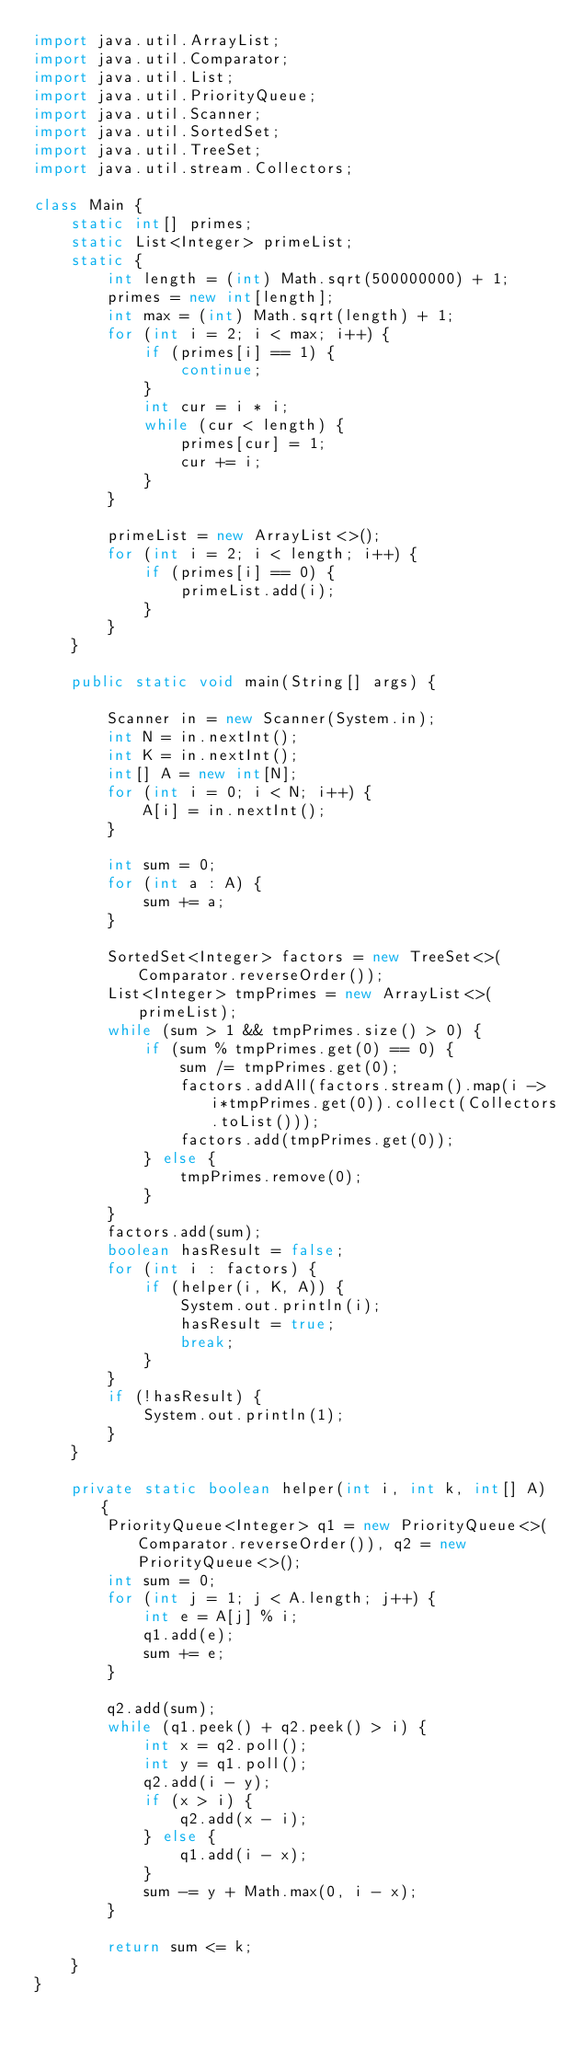<code> <loc_0><loc_0><loc_500><loc_500><_Java_>import java.util.ArrayList;
import java.util.Comparator;
import java.util.List;
import java.util.PriorityQueue;
import java.util.Scanner;
import java.util.SortedSet;
import java.util.TreeSet;
import java.util.stream.Collectors;

class Main {
    static int[] primes;
    static List<Integer> primeList;
    static {
        int length = (int) Math.sqrt(500000000) + 1;
        primes = new int[length];
        int max = (int) Math.sqrt(length) + 1;
        for (int i = 2; i < max; i++) {
            if (primes[i] == 1) {
                continue;
            }
            int cur = i * i;
            while (cur < length) {
                primes[cur] = 1;
                cur += i;
            }
        }

        primeList = new ArrayList<>();
        for (int i = 2; i < length; i++) {
            if (primes[i] == 0) {
                primeList.add(i);
            }
        }
    }

    public static void main(String[] args) {

        Scanner in = new Scanner(System.in);
        int N = in.nextInt();
        int K = in.nextInt();
        int[] A = new int[N];
        for (int i = 0; i < N; i++) {
            A[i] = in.nextInt();
        }

        int sum = 0;
        for (int a : A) {
            sum += a;
        }

        SortedSet<Integer> factors = new TreeSet<>(Comparator.reverseOrder());
        List<Integer> tmpPrimes = new ArrayList<>(primeList);
        while (sum > 1 && tmpPrimes.size() > 0) {
            if (sum % tmpPrimes.get(0) == 0) {
                sum /= tmpPrimes.get(0);
                factors.addAll(factors.stream().map(i -> i*tmpPrimes.get(0)).collect(Collectors.toList()));
                factors.add(tmpPrimes.get(0));
            } else {
                tmpPrimes.remove(0);
            }
        }
        factors.add(sum);
        boolean hasResult = false;
        for (int i : factors) {
            if (helper(i, K, A)) {
                System.out.println(i);
                hasResult = true;
                break;
            }
        }
        if (!hasResult) {
            System.out.println(1);
        }
    }

    private static boolean helper(int i, int k, int[] A) {
        PriorityQueue<Integer> q1 = new PriorityQueue<>(Comparator.reverseOrder()), q2 = new PriorityQueue<>();
        int sum = 0;
        for (int j = 1; j < A.length; j++) {
            int e = A[j] % i;
            q1.add(e);
            sum += e;
        }
        
        q2.add(sum);
        while (q1.peek() + q2.peek() > i) {
            int x = q2.poll();
            int y = q1.poll();
            q2.add(i - y);
            if (x > i) {
                q2.add(x - i);
            } else {
                q1.add(i - x);
            }
            sum -= y + Math.max(0, i - x);
        }
        
        return sum <= k;
    }
}</code> 